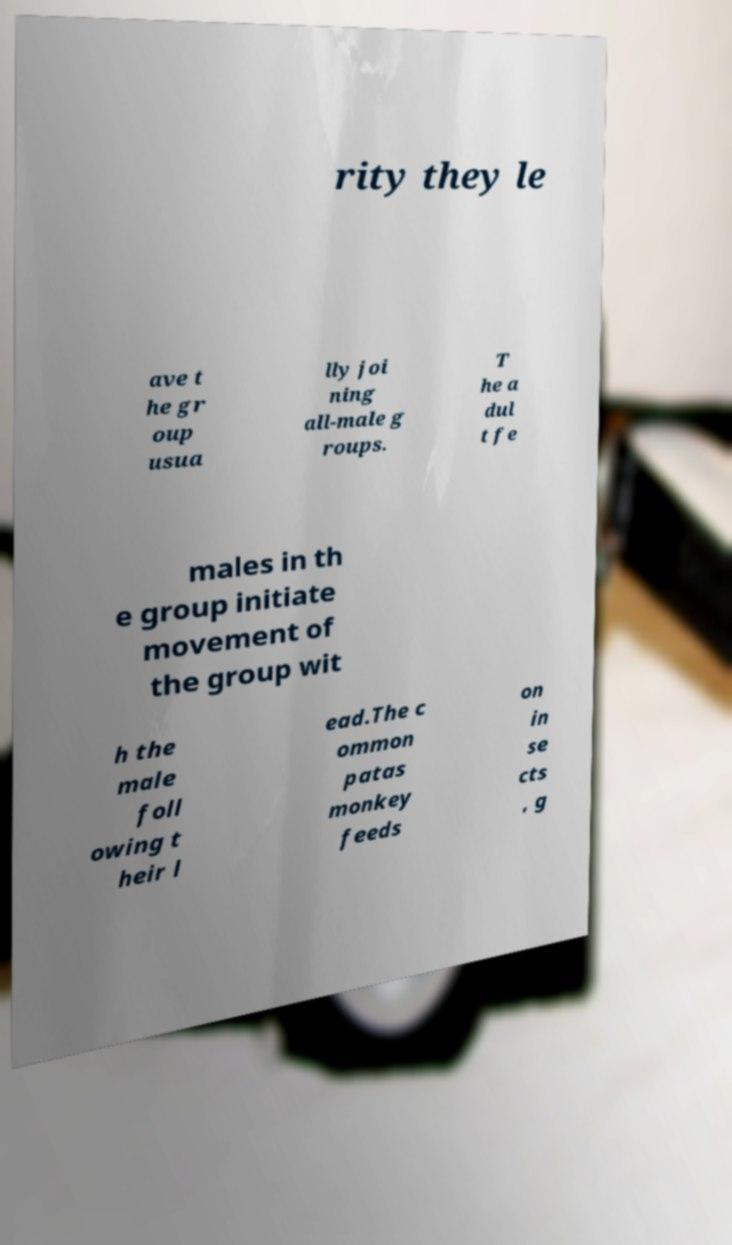For documentation purposes, I need the text within this image transcribed. Could you provide that? rity they le ave t he gr oup usua lly joi ning all-male g roups. T he a dul t fe males in th e group initiate movement of the group wit h the male foll owing t heir l ead.The c ommon patas monkey feeds on in se cts , g 